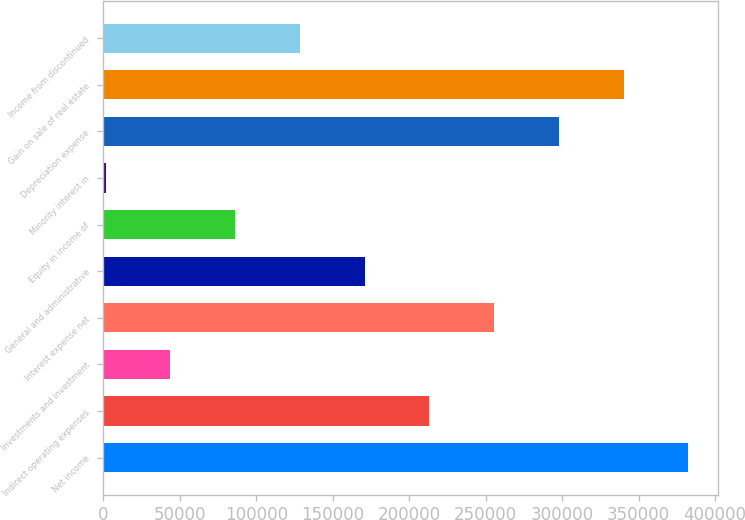Convert chart to OTSL. <chart><loc_0><loc_0><loc_500><loc_500><bar_chart><fcel>Net income<fcel>Indirect operating expenses<fcel>Investments and investment<fcel>Interest expense net<fcel>General and administrative<fcel>Equity in income of<fcel>Minority interest in<fcel>Depreciation expense<fcel>Gain on sale of real estate<fcel>Income from discontinued<nl><fcel>382428<fcel>213118<fcel>43808.4<fcel>255445<fcel>170791<fcel>86135.8<fcel>1481<fcel>297773<fcel>340100<fcel>128463<nl></chart> 